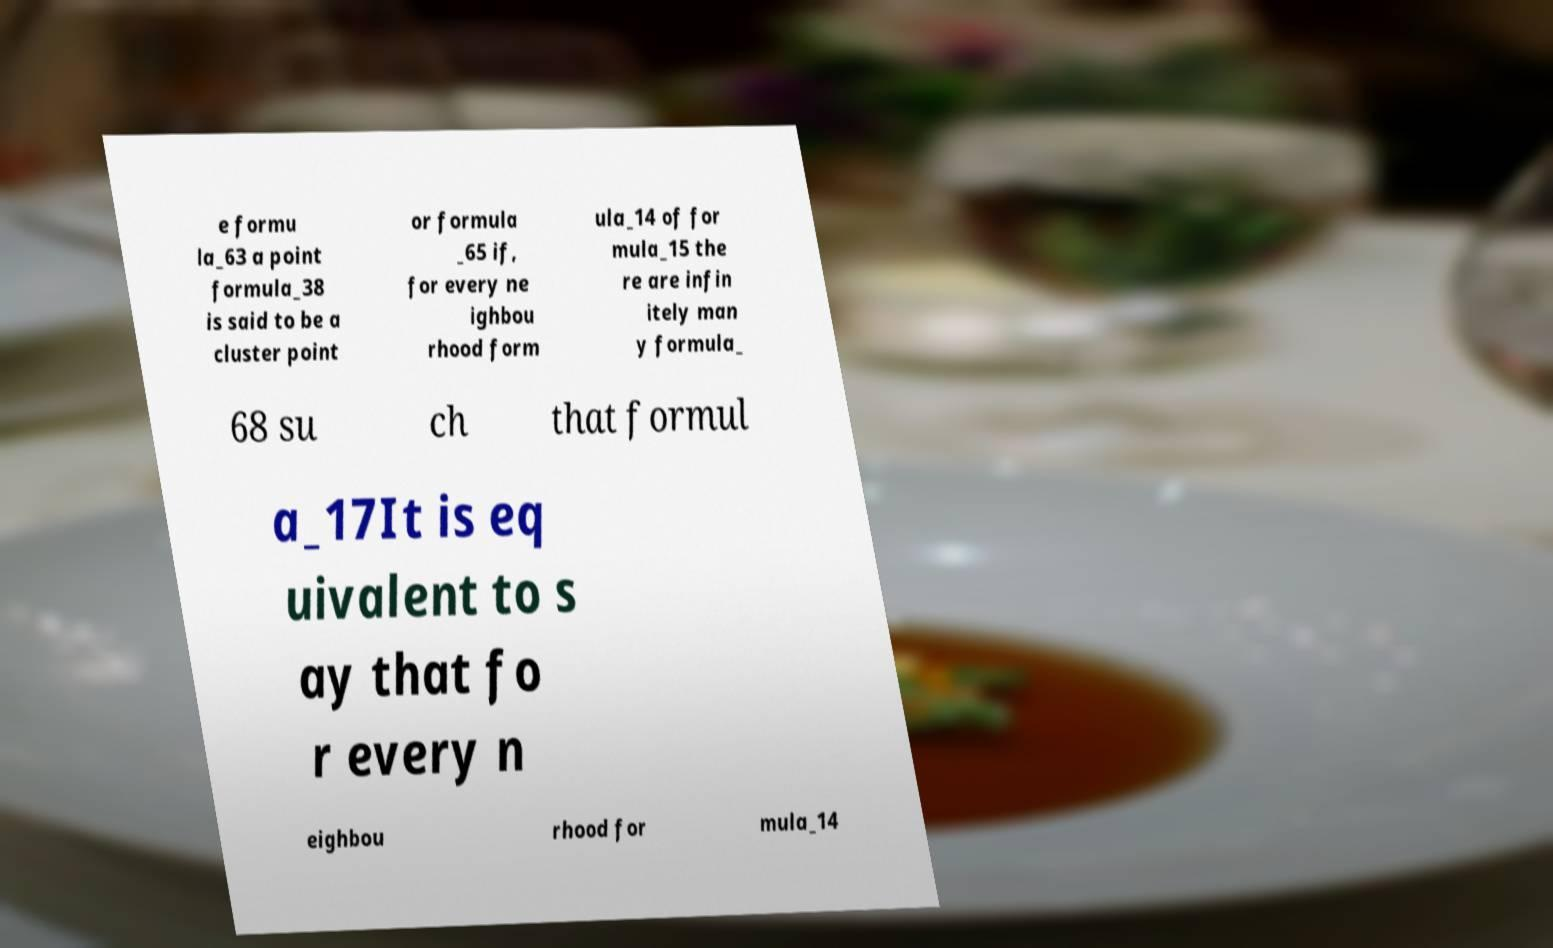Please read and relay the text visible in this image. What does it say? e formu la_63 a point formula_38 is said to be a cluster point or formula _65 if, for every ne ighbou rhood form ula_14 of for mula_15 the re are infin itely man y formula_ 68 su ch that formul a_17It is eq uivalent to s ay that fo r every n eighbou rhood for mula_14 